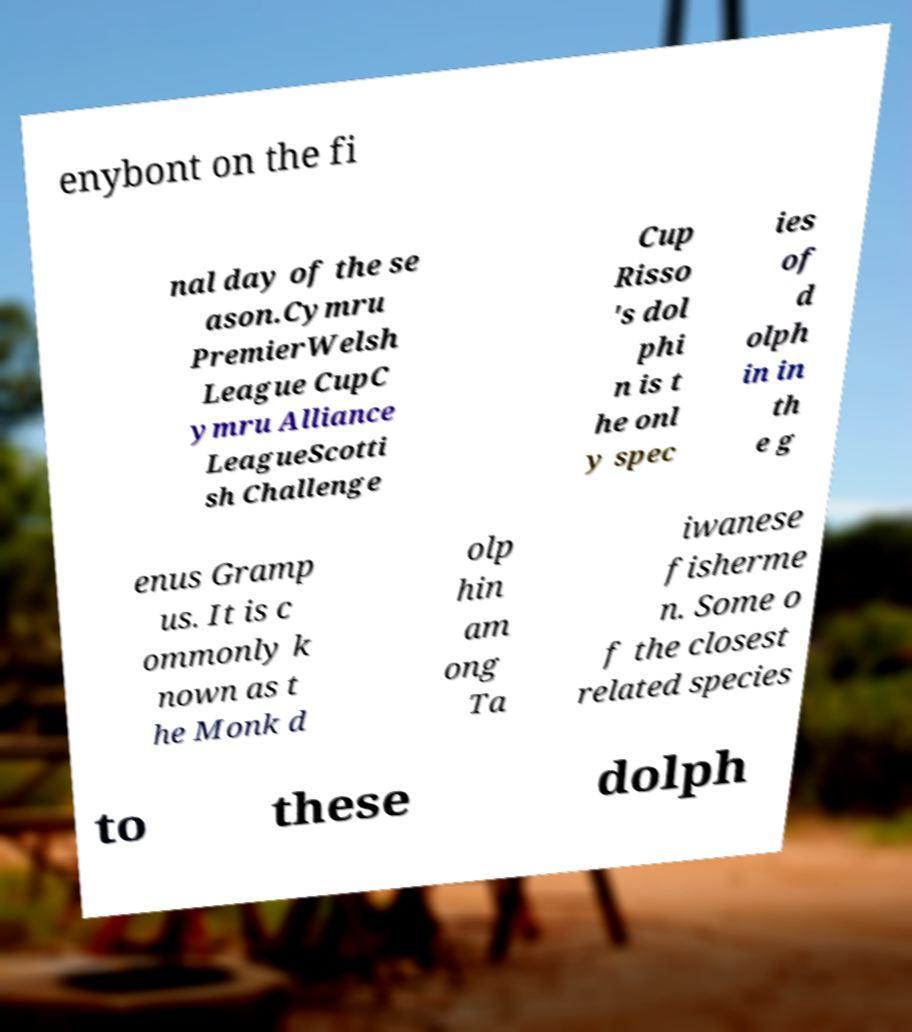I need the written content from this picture converted into text. Can you do that? enybont on the fi nal day of the se ason.Cymru PremierWelsh League CupC ymru Alliance LeagueScotti sh Challenge Cup Risso 's dol phi n is t he onl y spec ies of d olph in in th e g enus Gramp us. It is c ommonly k nown as t he Monk d olp hin am ong Ta iwanese fisherme n. Some o f the closest related species to these dolph 